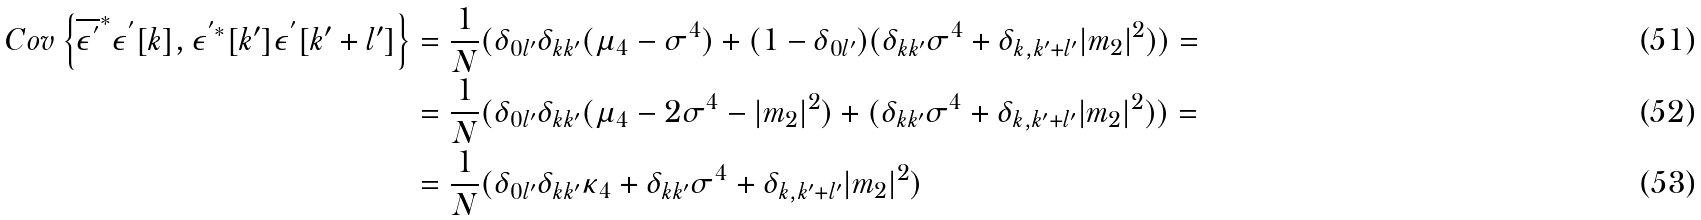<formula> <loc_0><loc_0><loc_500><loc_500>C o v \left \{ \overline { \epsilon ^ { ^ { \prime } } } ^ { * } \epsilon ^ { ^ { \prime } } [ k ] , \epsilon ^ { ^ { \prime } * } [ k ^ { \prime } ] \epsilon ^ { ^ { \prime } } [ k ^ { \prime } + l ^ { \prime } ] \right \} & = \frac { 1 } { N } ( \delta _ { 0 l ^ { \prime } } \delta _ { k k ^ { \prime } } ( \mu _ { 4 } - \sigma ^ { 4 } ) + ( 1 - \delta _ { 0 l ^ { \prime } } ) ( \delta _ { k k ^ { \prime } } \sigma ^ { 4 } + \delta _ { k , k ^ { \prime } + l ^ { \prime } } | m _ { 2 } | ^ { 2 } ) ) = \\ & = \frac { 1 } { N } ( \delta _ { 0 l ^ { \prime } } \delta _ { k k ^ { \prime } } ( \mu _ { 4 } - 2 \sigma ^ { 4 } - | m _ { 2 } | ^ { 2 } ) + ( \delta _ { k k ^ { \prime } } \sigma ^ { 4 } + \delta _ { k , k ^ { \prime } + l ^ { \prime } } | m _ { 2 } | ^ { 2 } ) ) = \\ & = \frac { 1 } { N } ( \delta _ { 0 l ^ { \prime } } \delta _ { k k ^ { \prime } } \kappa _ { 4 } + \delta _ { k k ^ { \prime } } \sigma ^ { 4 } + \delta _ { k , k ^ { \prime } + l ^ { \prime } } | m _ { 2 } | ^ { 2 } )</formula> 